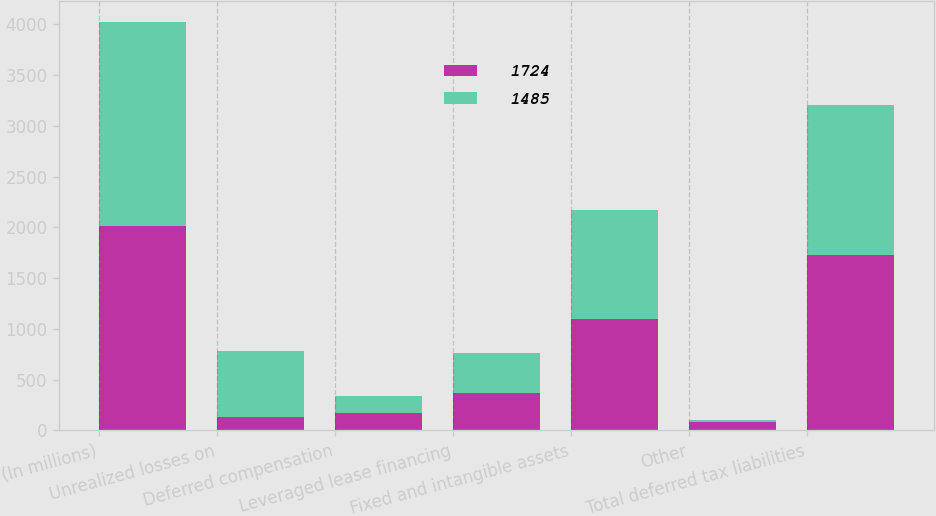Convert chart to OTSL. <chart><loc_0><loc_0><loc_500><loc_500><stacked_bar_chart><ecel><fcel>(In millions)<fcel>Unrealized losses on<fcel>Deferred compensation<fcel>Leveraged lease financing<fcel>Fixed and intangible assets<fcel>Other<fcel>Total deferred tax liabilities<nl><fcel>1724<fcel>2012<fcel>131<fcel>175<fcel>370<fcel>1099<fcel>81<fcel>1724<nl><fcel>1485<fcel>2011<fcel>651<fcel>162<fcel>397<fcel>1067<fcel>21<fcel>1485<nl></chart> 